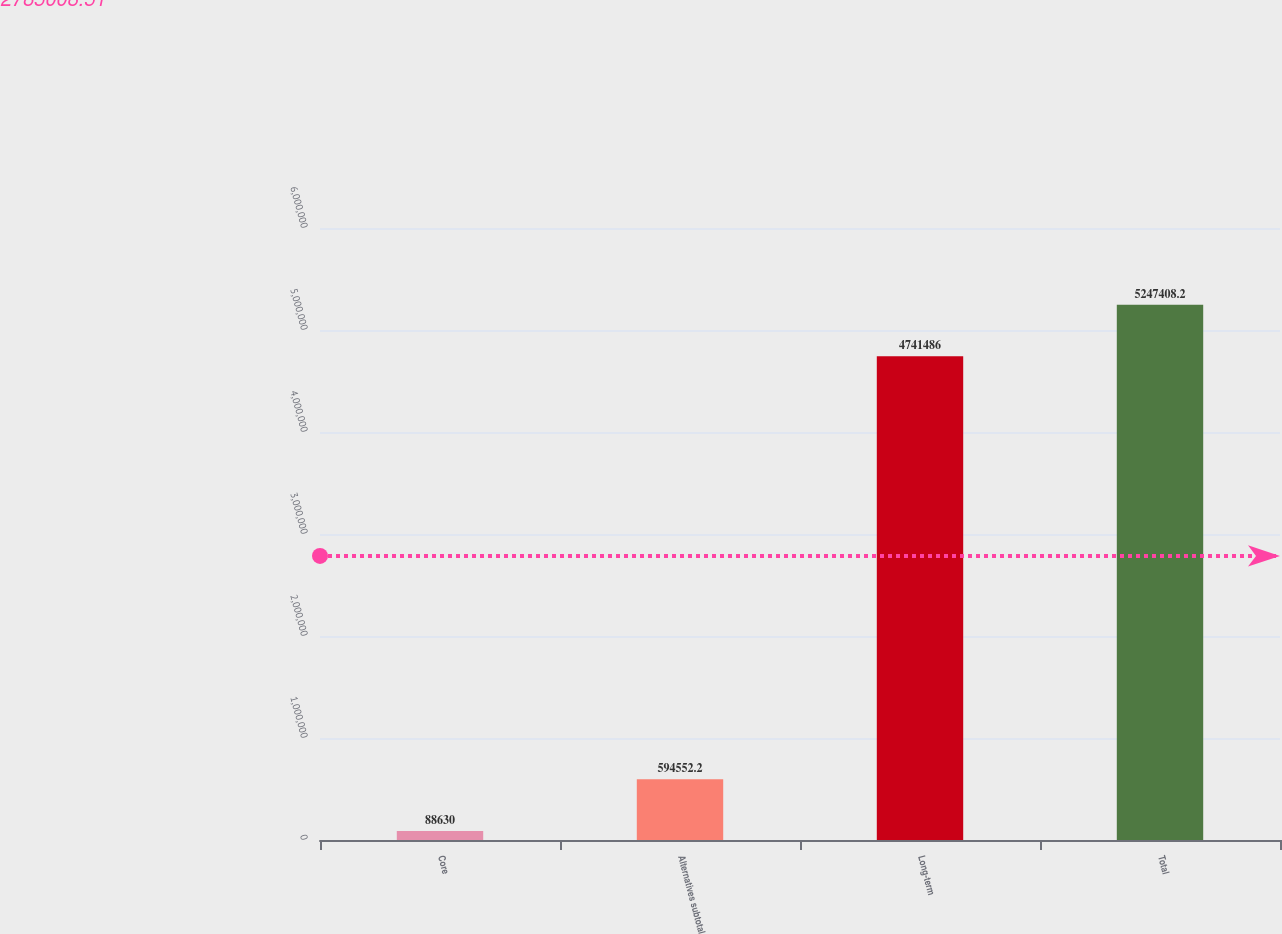Convert chart. <chart><loc_0><loc_0><loc_500><loc_500><bar_chart><fcel>Core<fcel>Alternatives subtotal<fcel>Long-term<fcel>Total<nl><fcel>88630<fcel>594552<fcel>4.74149e+06<fcel>5.24741e+06<nl></chart> 